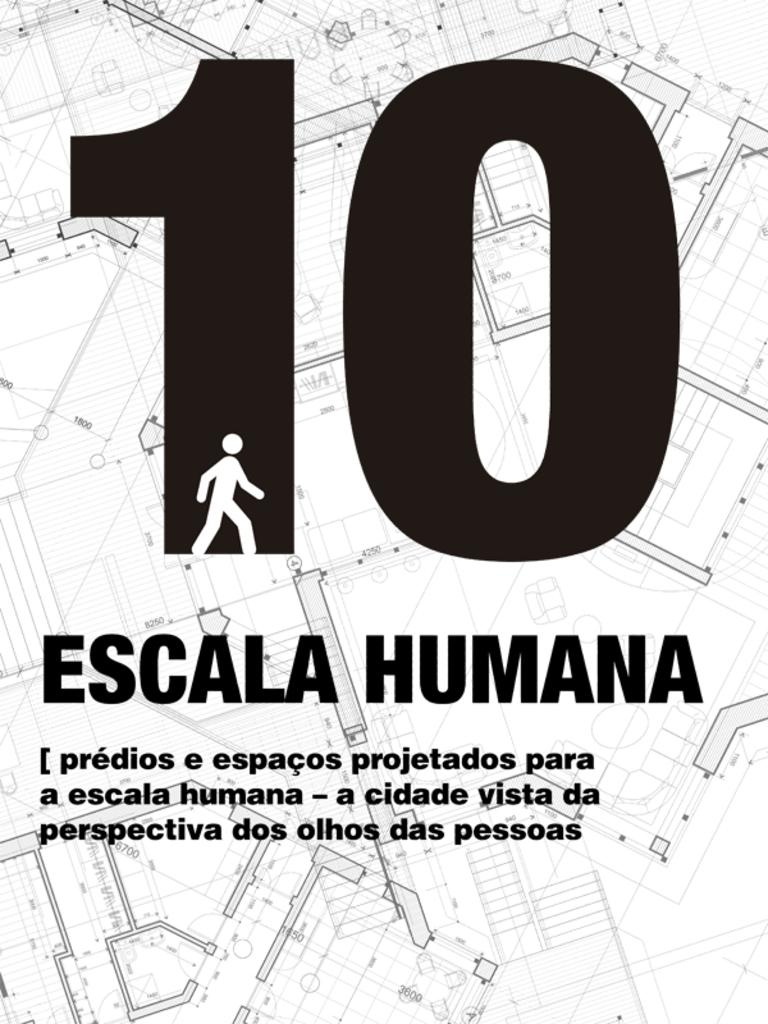What type of element is present in black color in the image? There is a number in black color in the image. What shape can be seen in the image? There is a shape in the form of a human in the image. Where are the words located in the image? The words in black color are at the bottom of the image. How many rabbits can be seen playing with the shape in the image? There are no rabbits present in the image. What is the development of the chin in the image? There is no chin or any reference to development in the image. 